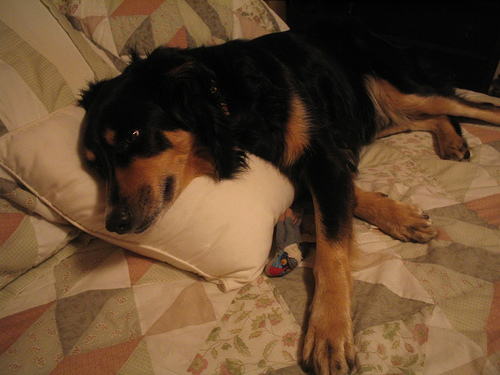<image>What is the design on the pillow? The design on the pillow is unknown. It could be solid, patchwork, striped, plain, or none. What is the design on the pillow? I don't know what design is on the pillow. It can be solid, patchwork, striped, or plain. 